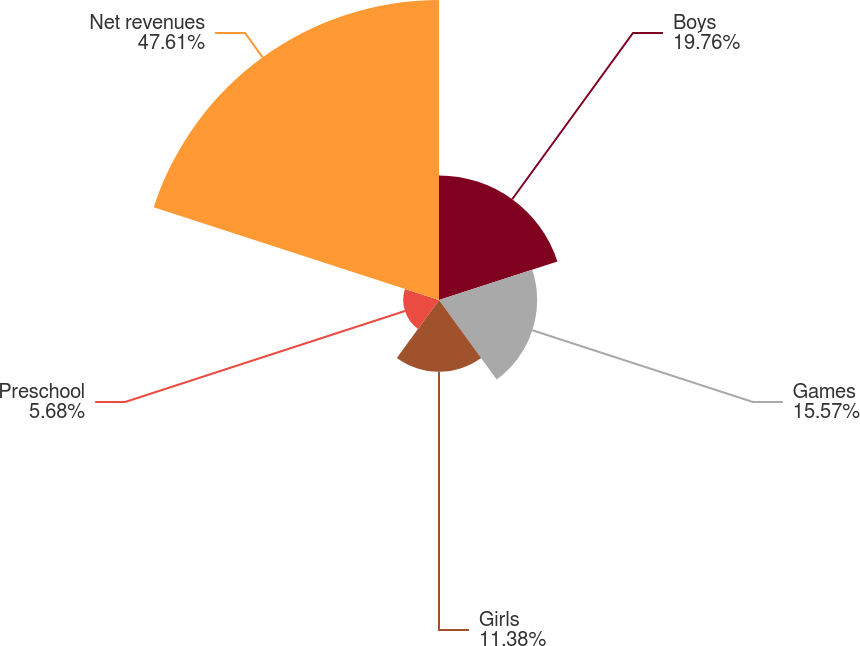Convert chart to OTSL. <chart><loc_0><loc_0><loc_500><loc_500><pie_chart><fcel>Boys<fcel>Games<fcel>Girls<fcel>Preschool<fcel>Net revenues<nl><fcel>19.76%<fcel>15.57%<fcel>11.38%<fcel>5.68%<fcel>47.6%<nl></chart> 